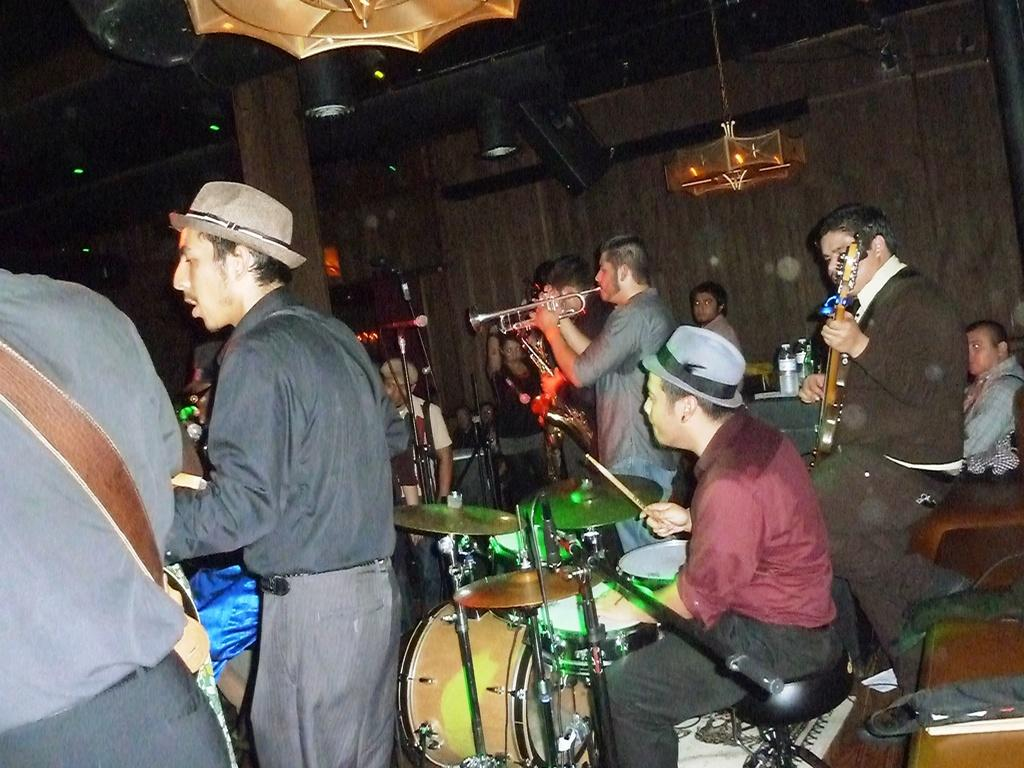How many people are in the image? There are people in the image, but the exact number is not specified. What are the people doing in the image? The people are performing in the image. What activity are the people engaged in while performing? The people are playing musical instruments. Where is the throne located in the image? There is no throne present in the image. How does the pollution affect the performance in the image? There is no mention of pollution in the image, so it cannot affect the performance. 